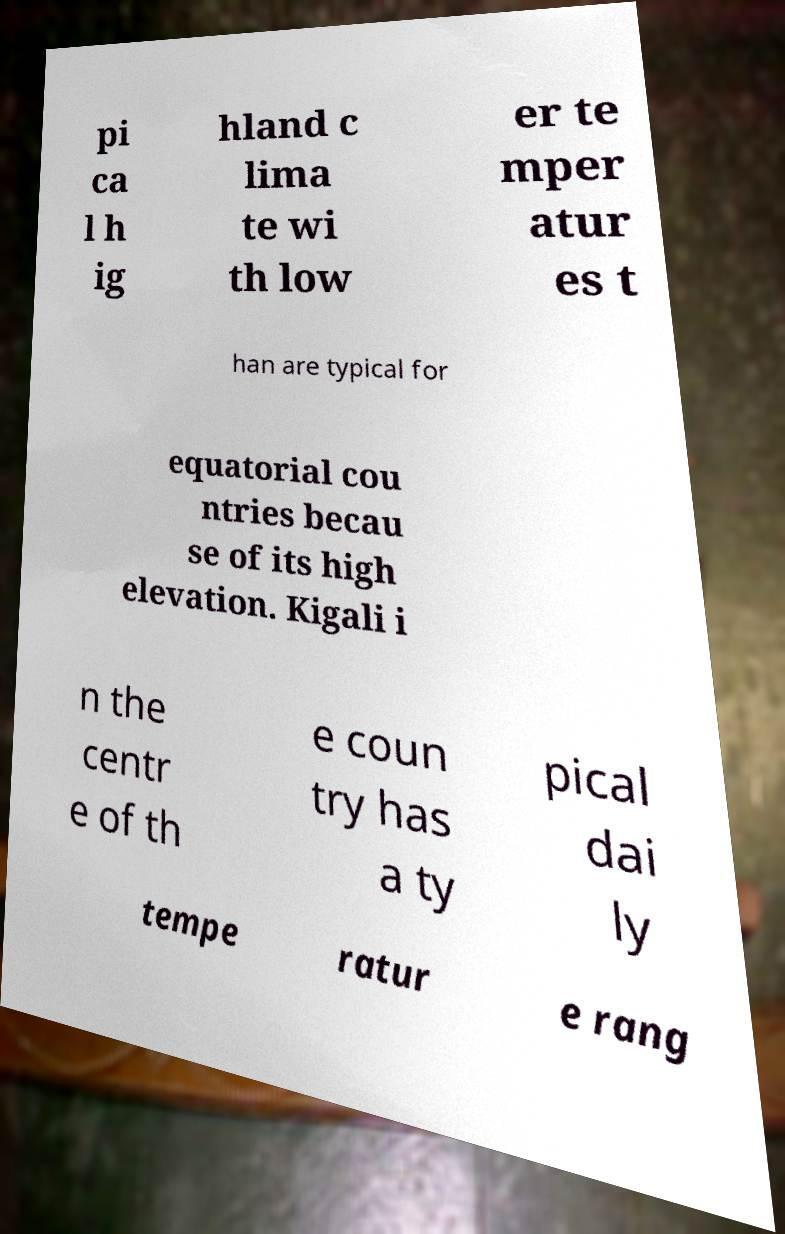What messages or text are displayed in this image? I need them in a readable, typed format. pi ca l h ig hland c lima te wi th low er te mper atur es t han are typical for equatorial cou ntries becau se of its high elevation. Kigali i n the centr e of th e coun try has a ty pical dai ly tempe ratur e rang 